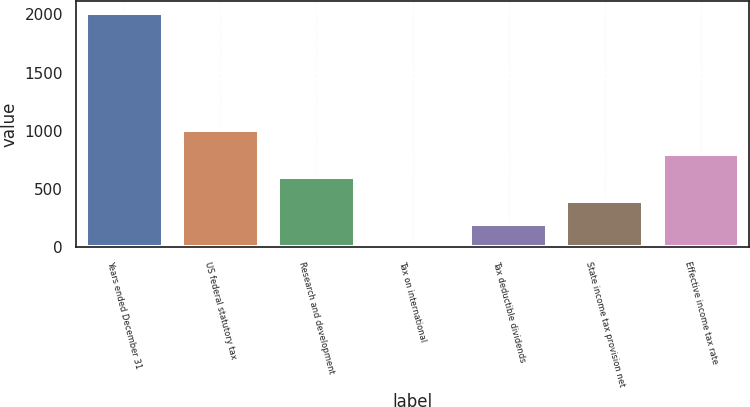<chart> <loc_0><loc_0><loc_500><loc_500><bar_chart><fcel>Years ended December 31<fcel>US federal statutory tax<fcel>Research and development<fcel>Tax on international<fcel>Tax deductible dividends<fcel>State income tax provision net<fcel>Effective income tax rate<nl><fcel>2014<fcel>1007.1<fcel>604.34<fcel>0.2<fcel>201.58<fcel>402.96<fcel>805.72<nl></chart> 